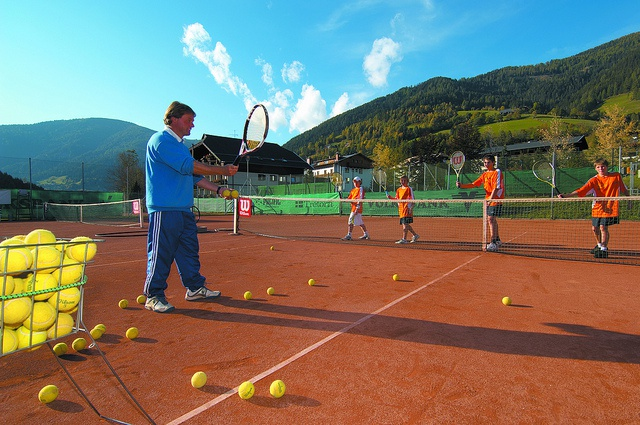Describe the objects in this image and their specific colors. I can see sports ball in cyan, gold, brown, and olive tones, people in cyan, blue, navy, black, and maroon tones, people in cyan, maroon, black, and red tones, people in cyan, maroon, black, and red tones, and tennis racket in cyan, ivory, black, gray, and lightblue tones in this image. 